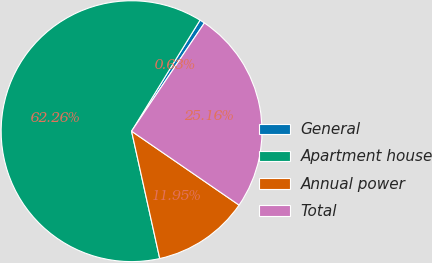<chart> <loc_0><loc_0><loc_500><loc_500><pie_chart><fcel>General<fcel>Apartment house<fcel>Annual power<fcel>Total<nl><fcel>0.63%<fcel>62.26%<fcel>11.95%<fcel>25.16%<nl></chart> 